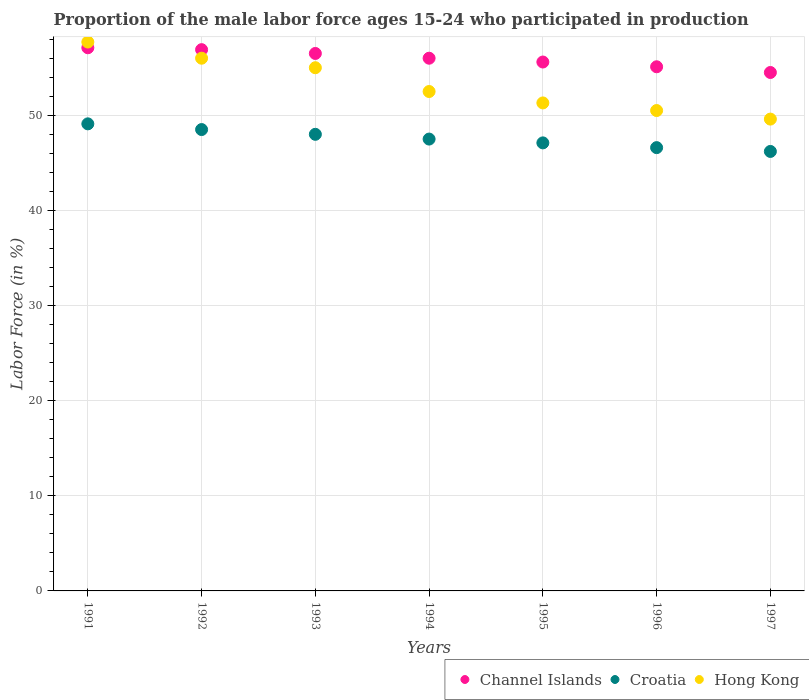Is the number of dotlines equal to the number of legend labels?
Make the answer very short. Yes. What is the proportion of the male labor force who participated in production in Hong Kong in 1997?
Offer a very short reply. 49.6. Across all years, what is the maximum proportion of the male labor force who participated in production in Croatia?
Give a very brief answer. 49.1. Across all years, what is the minimum proportion of the male labor force who participated in production in Channel Islands?
Ensure brevity in your answer.  54.5. In which year was the proportion of the male labor force who participated in production in Hong Kong maximum?
Offer a terse response. 1991. In which year was the proportion of the male labor force who participated in production in Hong Kong minimum?
Your response must be concise. 1997. What is the total proportion of the male labor force who participated in production in Channel Islands in the graph?
Give a very brief answer. 391.7. What is the difference between the proportion of the male labor force who participated in production in Hong Kong in 1991 and that in 1997?
Make the answer very short. 8.1. What is the difference between the proportion of the male labor force who participated in production in Hong Kong in 1991 and the proportion of the male labor force who participated in production in Channel Islands in 1992?
Your answer should be very brief. 0.8. What is the average proportion of the male labor force who participated in production in Channel Islands per year?
Your response must be concise. 55.96. What is the ratio of the proportion of the male labor force who participated in production in Channel Islands in 1995 to that in 1997?
Provide a short and direct response. 1.02. Is the difference between the proportion of the male labor force who participated in production in Channel Islands in 1991 and 1994 greater than the difference between the proportion of the male labor force who participated in production in Croatia in 1991 and 1994?
Your answer should be compact. No. What is the difference between the highest and the second highest proportion of the male labor force who participated in production in Channel Islands?
Provide a short and direct response. 0.2. What is the difference between the highest and the lowest proportion of the male labor force who participated in production in Channel Islands?
Your answer should be compact. 2.6. Is the sum of the proportion of the male labor force who participated in production in Croatia in 1991 and 1993 greater than the maximum proportion of the male labor force who participated in production in Channel Islands across all years?
Your response must be concise. Yes. Does the proportion of the male labor force who participated in production in Channel Islands monotonically increase over the years?
Your answer should be very brief. No. Is the proportion of the male labor force who participated in production in Channel Islands strictly greater than the proportion of the male labor force who participated in production in Croatia over the years?
Make the answer very short. Yes. Is the proportion of the male labor force who participated in production in Croatia strictly less than the proportion of the male labor force who participated in production in Channel Islands over the years?
Your answer should be compact. Yes. How many dotlines are there?
Provide a succinct answer. 3. Are the values on the major ticks of Y-axis written in scientific E-notation?
Your answer should be very brief. No. Does the graph contain grids?
Provide a short and direct response. Yes. Where does the legend appear in the graph?
Offer a terse response. Bottom right. What is the title of the graph?
Offer a terse response. Proportion of the male labor force ages 15-24 who participated in production. What is the label or title of the X-axis?
Make the answer very short. Years. What is the label or title of the Y-axis?
Offer a terse response. Labor Force (in %). What is the Labor Force (in %) in Channel Islands in 1991?
Offer a terse response. 57.1. What is the Labor Force (in %) in Croatia in 1991?
Offer a very short reply. 49.1. What is the Labor Force (in %) in Hong Kong in 1991?
Keep it short and to the point. 57.7. What is the Labor Force (in %) of Channel Islands in 1992?
Your response must be concise. 56.9. What is the Labor Force (in %) of Croatia in 1992?
Provide a succinct answer. 48.5. What is the Labor Force (in %) in Hong Kong in 1992?
Offer a terse response. 56. What is the Labor Force (in %) of Channel Islands in 1993?
Provide a succinct answer. 56.5. What is the Labor Force (in %) of Croatia in 1993?
Provide a succinct answer. 48. What is the Labor Force (in %) of Croatia in 1994?
Provide a short and direct response. 47.5. What is the Labor Force (in %) of Hong Kong in 1994?
Your answer should be compact. 52.5. What is the Labor Force (in %) of Channel Islands in 1995?
Provide a succinct answer. 55.6. What is the Labor Force (in %) of Croatia in 1995?
Make the answer very short. 47.1. What is the Labor Force (in %) of Hong Kong in 1995?
Your answer should be very brief. 51.3. What is the Labor Force (in %) in Channel Islands in 1996?
Keep it short and to the point. 55.1. What is the Labor Force (in %) of Croatia in 1996?
Ensure brevity in your answer.  46.6. What is the Labor Force (in %) in Hong Kong in 1996?
Your answer should be compact. 50.5. What is the Labor Force (in %) in Channel Islands in 1997?
Make the answer very short. 54.5. What is the Labor Force (in %) of Croatia in 1997?
Make the answer very short. 46.2. What is the Labor Force (in %) of Hong Kong in 1997?
Keep it short and to the point. 49.6. Across all years, what is the maximum Labor Force (in %) of Channel Islands?
Make the answer very short. 57.1. Across all years, what is the maximum Labor Force (in %) of Croatia?
Make the answer very short. 49.1. Across all years, what is the maximum Labor Force (in %) of Hong Kong?
Your answer should be compact. 57.7. Across all years, what is the minimum Labor Force (in %) of Channel Islands?
Your response must be concise. 54.5. Across all years, what is the minimum Labor Force (in %) of Croatia?
Your answer should be compact. 46.2. Across all years, what is the minimum Labor Force (in %) in Hong Kong?
Keep it short and to the point. 49.6. What is the total Labor Force (in %) of Channel Islands in the graph?
Ensure brevity in your answer.  391.7. What is the total Labor Force (in %) of Croatia in the graph?
Offer a terse response. 333. What is the total Labor Force (in %) of Hong Kong in the graph?
Offer a very short reply. 372.6. What is the difference between the Labor Force (in %) of Croatia in 1991 and that in 1993?
Provide a short and direct response. 1.1. What is the difference between the Labor Force (in %) of Croatia in 1991 and that in 1994?
Your response must be concise. 1.6. What is the difference between the Labor Force (in %) of Hong Kong in 1991 and that in 1994?
Make the answer very short. 5.2. What is the difference between the Labor Force (in %) of Channel Islands in 1991 and that in 1996?
Your answer should be compact. 2. What is the difference between the Labor Force (in %) of Croatia in 1991 and that in 1997?
Provide a succinct answer. 2.9. What is the difference between the Labor Force (in %) of Croatia in 1992 and that in 1993?
Your response must be concise. 0.5. What is the difference between the Labor Force (in %) in Hong Kong in 1992 and that in 1993?
Make the answer very short. 1. What is the difference between the Labor Force (in %) in Channel Islands in 1992 and that in 1994?
Make the answer very short. 0.9. What is the difference between the Labor Force (in %) in Channel Islands in 1992 and that in 1995?
Offer a terse response. 1.3. What is the difference between the Labor Force (in %) in Croatia in 1992 and that in 1996?
Make the answer very short. 1.9. What is the difference between the Labor Force (in %) in Hong Kong in 1992 and that in 1997?
Your answer should be very brief. 6.4. What is the difference between the Labor Force (in %) in Hong Kong in 1993 and that in 1994?
Provide a succinct answer. 2.5. What is the difference between the Labor Force (in %) in Channel Islands in 1993 and that in 1995?
Give a very brief answer. 0.9. What is the difference between the Labor Force (in %) of Croatia in 1993 and that in 1995?
Make the answer very short. 0.9. What is the difference between the Labor Force (in %) in Hong Kong in 1993 and that in 1995?
Ensure brevity in your answer.  3.7. What is the difference between the Labor Force (in %) of Channel Islands in 1993 and that in 1996?
Ensure brevity in your answer.  1.4. What is the difference between the Labor Force (in %) in Croatia in 1993 and that in 1996?
Your answer should be compact. 1.4. What is the difference between the Labor Force (in %) of Channel Islands in 1994 and that in 1995?
Keep it short and to the point. 0.4. What is the difference between the Labor Force (in %) of Croatia in 1994 and that in 1996?
Give a very brief answer. 0.9. What is the difference between the Labor Force (in %) in Hong Kong in 1994 and that in 1996?
Your answer should be very brief. 2. What is the difference between the Labor Force (in %) of Croatia in 1994 and that in 1997?
Provide a short and direct response. 1.3. What is the difference between the Labor Force (in %) of Hong Kong in 1994 and that in 1997?
Ensure brevity in your answer.  2.9. What is the difference between the Labor Force (in %) of Channel Islands in 1995 and that in 1997?
Your answer should be very brief. 1.1. What is the difference between the Labor Force (in %) of Channel Islands in 1996 and that in 1997?
Ensure brevity in your answer.  0.6. What is the difference between the Labor Force (in %) in Croatia in 1996 and that in 1997?
Ensure brevity in your answer.  0.4. What is the difference between the Labor Force (in %) in Hong Kong in 1996 and that in 1997?
Your answer should be compact. 0.9. What is the difference between the Labor Force (in %) of Channel Islands in 1991 and the Labor Force (in %) of Croatia in 1992?
Your answer should be compact. 8.6. What is the difference between the Labor Force (in %) in Channel Islands in 1991 and the Labor Force (in %) in Hong Kong in 1992?
Your response must be concise. 1.1. What is the difference between the Labor Force (in %) in Channel Islands in 1991 and the Labor Force (in %) in Croatia in 1993?
Provide a succinct answer. 9.1. What is the difference between the Labor Force (in %) of Channel Islands in 1991 and the Labor Force (in %) of Hong Kong in 1993?
Provide a short and direct response. 2.1. What is the difference between the Labor Force (in %) of Channel Islands in 1991 and the Labor Force (in %) of Hong Kong in 1994?
Provide a short and direct response. 4.6. What is the difference between the Labor Force (in %) of Croatia in 1991 and the Labor Force (in %) of Hong Kong in 1994?
Your response must be concise. -3.4. What is the difference between the Labor Force (in %) of Channel Islands in 1991 and the Labor Force (in %) of Hong Kong in 1995?
Your answer should be very brief. 5.8. What is the difference between the Labor Force (in %) of Croatia in 1991 and the Labor Force (in %) of Hong Kong in 1995?
Provide a succinct answer. -2.2. What is the difference between the Labor Force (in %) of Channel Islands in 1991 and the Labor Force (in %) of Hong Kong in 1996?
Your answer should be very brief. 6.6. What is the difference between the Labor Force (in %) in Croatia in 1991 and the Labor Force (in %) in Hong Kong in 1996?
Provide a short and direct response. -1.4. What is the difference between the Labor Force (in %) of Channel Islands in 1991 and the Labor Force (in %) of Hong Kong in 1997?
Your answer should be compact. 7.5. What is the difference between the Labor Force (in %) of Channel Islands in 1992 and the Labor Force (in %) of Hong Kong in 1993?
Your answer should be very brief. 1.9. What is the difference between the Labor Force (in %) of Channel Islands in 1992 and the Labor Force (in %) of Croatia in 1994?
Give a very brief answer. 9.4. What is the difference between the Labor Force (in %) in Channel Islands in 1992 and the Labor Force (in %) in Hong Kong in 1994?
Provide a succinct answer. 4.4. What is the difference between the Labor Force (in %) in Channel Islands in 1992 and the Labor Force (in %) in Croatia in 1995?
Your answer should be compact. 9.8. What is the difference between the Labor Force (in %) in Channel Islands in 1992 and the Labor Force (in %) in Hong Kong in 1995?
Your response must be concise. 5.6. What is the difference between the Labor Force (in %) in Croatia in 1992 and the Labor Force (in %) in Hong Kong in 1995?
Offer a very short reply. -2.8. What is the difference between the Labor Force (in %) in Channel Islands in 1992 and the Labor Force (in %) in Croatia in 1996?
Your answer should be very brief. 10.3. What is the difference between the Labor Force (in %) in Channel Islands in 1992 and the Labor Force (in %) in Hong Kong in 1996?
Provide a short and direct response. 6.4. What is the difference between the Labor Force (in %) in Croatia in 1992 and the Labor Force (in %) in Hong Kong in 1996?
Your answer should be very brief. -2. What is the difference between the Labor Force (in %) in Channel Islands in 1992 and the Labor Force (in %) in Croatia in 1997?
Offer a very short reply. 10.7. What is the difference between the Labor Force (in %) of Channel Islands in 1992 and the Labor Force (in %) of Hong Kong in 1997?
Offer a very short reply. 7.3. What is the difference between the Labor Force (in %) in Croatia in 1992 and the Labor Force (in %) in Hong Kong in 1997?
Offer a very short reply. -1.1. What is the difference between the Labor Force (in %) of Channel Islands in 1993 and the Labor Force (in %) of Croatia in 1994?
Provide a short and direct response. 9. What is the difference between the Labor Force (in %) of Channel Islands in 1993 and the Labor Force (in %) of Hong Kong in 1994?
Provide a short and direct response. 4. What is the difference between the Labor Force (in %) of Channel Islands in 1993 and the Labor Force (in %) of Hong Kong in 1995?
Offer a very short reply. 5.2. What is the difference between the Labor Force (in %) in Channel Islands in 1993 and the Labor Force (in %) in Croatia in 1996?
Provide a short and direct response. 9.9. What is the difference between the Labor Force (in %) in Channel Islands in 1993 and the Labor Force (in %) in Hong Kong in 1996?
Your answer should be very brief. 6. What is the difference between the Labor Force (in %) in Channel Islands in 1993 and the Labor Force (in %) in Croatia in 1997?
Your answer should be very brief. 10.3. What is the difference between the Labor Force (in %) in Channel Islands in 1993 and the Labor Force (in %) in Hong Kong in 1997?
Provide a succinct answer. 6.9. What is the difference between the Labor Force (in %) of Channel Islands in 1994 and the Labor Force (in %) of Hong Kong in 1995?
Keep it short and to the point. 4.7. What is the difference between the Labor Force (in %) in Croatia in 1994 and the Labor Force (in %) in Hong Kong in 1995?
Make the answer very short. -3.8. What is the difference between the Labor Force (in %) in Channel Islands in 1994 and the Labor Force (in %) in Croatia in 1996?
Provide a succinct answer. 9.4. What is the difference between the Labor Force (in %) in Channel Islands in 1994 and the Labor Force (in %) in Hong Kong in 1996?
Provide a succinct answer. 5.5. What is the difference between the Labor Force (in %) in Croatia in 1994 and the Labor Force (in %) in Hong Kong in 1996?
Your answer should be compact. -3. What is the difference between the Labor Force (in %) in Channel Islands in 1994 and the Labor Force (in %) in Croatia in 1997?
Offer a terse response. 9.8. What is the difference between the Labor Force (in %) of Channel Islands in 1994 and the Labor Force (in %) of Hong Kong in 1997?
Your answer should be very brief. 6.4. What is the difference between the Labor Force (in %) in Croatia in 1994 and the Labor Force (in %) in Hong Kong in 1997?
Make the answer very short. -2.1. What is the difference between the Labor Force (in %) in Channel Islands in 1995 and the Labor Force (in %) in Croatia in 1996?
Provide a short and direct response. 9. What is the difference between the Labor Force (in %) of Channel Islands in 1995 and the Labor Force (in %) of Hong Kong in 1996?
Give a very brief answer. 5.1. What is the difference between the Labor Force (in %) in Croatia in 1995 and the Labor Force (in %) in Hong Kong in 1996?
Give a very brief answer. -3.4. What is the difference between the Labor Force (in %) in Channel Islands in 1995 and the Labor Force (in %) in Croatia in 1997?
Your response must be concise. 9.4. What is the difference between the Labor Force (in %) of Channel Islands in 1995 and the Labor Force (in %) of Hong Kong in 1997?
Provide a succinct answer. 6. What is the difference between the Labor Force (in %) of Channel Islands in 1996 and the Labor Force (in %) of Croatia in 1997?
Your answer should be compact. 8.9. What is the difference between the Labor Force (in %) in Channel Islands in 1996 and the Labor Force (in %) in Hong Kong in 1997?
Ensure brevity in your answer.  5.5. What is the average Labor Force (in %) of Channel Islands per year?
Your answer should be compact. 55.96. What is the average Labor Force (in %) in Croatia per year?
Offer a very short reply. 47.57. What is the average Labor Force (in %) in Hong Kong per year?
Your answer should be compact. 53.23. In the year 1991, what is the difference between the Labor Force (in %) of Croatia and Labor Force (in %) of Hong Kong?
Give a very brief answer. -8.6. In the year 1992, what is the difference between the Labor Force (in %) of Channel Islands and Labor Force (in %) of Croatia?
Provide a succinct answer. 8.4. In the year 1993, what is the difference between the Labor Force (in %) of Channel Islands and Labor Force (in %) of Hong Kong?
Ensure brevity in your answer.  1.5. In the year 1993, what is the difference between the Labor Force (in %) in Croatia and Labor Force (in %) in Hong Kong?
Your response must be concise. -7. In the year 1994, what is the difference between the Labor Force (in %) in Channel Islands and Labor Force (in %) in Hong Kong?
Give a very brief answer. 3.5. In the year 1994, what is the difference between the Labor Force (in %) in Croatia and Labor Force (in %) in Hong Kong?
Give a very brief answer. -5. In the year 1995, what is the difference between the Labor Force (in %) in Croatia and Labor Force (in %) in Hong Kong?
Keep it short and to the point. -4.2. In the year 1996, what is the difference between the Labor Force (in %) in Croatia and Labor Force (in %) in Hong Kong?
Give a very brief answer. -3.9. In the year 1997, what is the difference between the Labor Force (in %) of Channel Islands and Labor Force (in %) of Hong Kong?
Your response must be concise. 4.9. What is the ratio of the Labor Force (in %) of Channel Islands in 1991 to that in 1992?
Give a very brief answer. 1. What is the ratio of the Labor Force (in %) of Croatia in 1991 to that in 1992?
Ensure brevity in your answer.  1.01. What is the ratio of the Labor Force (in %) of Hong Kong in 1991 to that in 1992?
Your response must be concise. 1.03. What is the ratio of the Labor Force (in %) in Channel Islands in 1991 to that in 1993?
Give a very brief answer. 1.01. What is the ratio of the Labor Force (in %) in Croatia in 1991 to that in 1993?
Provide a short and direct response. 1.02. What is the ratio of the Labor Force (in %) in Hong Kong in 1991 to that in 1993?
Your answer should be very brief. 1.05. What is the ratio of the Labor Force (in %) of Channel Islands in 1991 to that in 1994?
Your answer should be compact. 1.02. What is the ratio of the Labor Force (in %) in Croatia in 1991 to that in 1994?
Provide a succinct answer. 1.03. What is the ratio of the Labor Force (in %) of Hong Kong in 1991 to that in 1994?
Your answer should be very brief. 1.1. What is the ratio of the Labor Force (in %) in Channel Islands in 1991 to that in 1995?
Give a very brief answer. 1.03. What is the ratio of the Labor Force (in %) in Croatia in 1991 to that in 1995?
Ensure brevity in your answer.  1.04. What is the ratio of the Labor Force (in %) of Hong Kong in 1991 to that in 1995?
Provide a succinct answer. 1.12. What is the ratio of the Labor Force (in %) of Channel Islands in 1991 to that in 1996?
Provide a succinct answer. 1.04. What is the ratio of the Labor Force (in %) in Croatia in 1991 to that in 1996?
Ensure brevity in your answer.  1.05. What is the ratio of the Labor Force (in %) in Hong Kong in 1991 to that in 1996?
Your response must be concise. 1.14. What is the ratio of the Labor Force (in %) in Channel Islands in 1991 to that in 1997?
Your answer should be compact. 1.05. What is the ratio of the Labor Force (in %) in Croatia in 1991 to that in 1997?
Your answer should be compact. 1.06. What is the ratio of the Labor Force (in %) in Hong Kong in 1991 to that in 1997?
Give a very brief answer. 1.16. What is the ratio of the Labor Force (in %) in Channel Islands in 1992 to that in 1993?
Provide a short and direct response. 1.01. What is the ratio of the Labor Force (in %) of Croatia in 1992 to that in 1993?
Provide a short and direct response. 1.01. What is the ratio of the Labor Force (in %) of Hong Kong in 1992 to that in 1993?
Offer a very short reply. 1.02. What is the ratio of the Labor Force (in %) in Channel Islands in 1992 to that in 1994?
Give a very brief answer. 1.02. What is the ratio of the Labor Force (in %) in Croatia in 1992 to that in 1994?
Offer a terse response. 1.02. What is the ratio of the Labor Force (in %) of Hong Kong in 1992 to that in 1994?
Make the answer very short. 1.07. What is the ratio of the Labor Force (in %) of Channel Islands in 1992 to that in 1995?
Your answer should be compact. 1.02. What is the ratio of the Labor Force (in %) in Croatia in 1992 to that in 1995?
Your answer should be compact. 1.03. What is the ratio of the Labor Force (in %) in Hong Kong in 1992 to that in 1995?
Provide a succinct answer. 1.09. What is the ratio of the Labor Force (in %) in Channel Islands in 1992 to that in 1996?
Give a very brief answer. 1.03. What is the ratio of the Labor Force (in %) of Croatia in 1992 to that in 1996?
Your answer should be compact. 1.04. What is the ratio of the Labor Force (in %) of Hong Kong in 1992 to that in 1996?
Make the answer very short. 1.11. What is the ratio of the Labor Force (in %) of Channel Islands in 1992 to that in 1997?
Ensure brevity in your answer.  1.04. What is the ratio of the Labor Force (in %) in Croatia in 1992 to that in 1997?
Your response must be concise. 1.05. What is the ratio of the Labor Force (in %) in Hong Kong in 1992 to that in 1997?
Give a very brief answer. 1.13. What is the ratio of the Labor Force (in %) of Channel Islands in 1993 to that in 1994?
Give a very brief answer. 1.01. What is the ratio of the Labor Force (in %) of Croatia in 1993 to that in 1994?
Provide a short and direct response. 1.01. What is the ratio of the Labor Force (in %) of Hong Kong in 1993 to that in 1994?
Your answer should be very brief. 1.05. What is the ratio of the Labor Force (in %) of Channel Islands in 1993 to that in 1995?
Your answer should be very brief. 1.02. What is the ratio of the Labor Force (in %) in Croatia in 1993 to that in 1995?
Keep it short and to the point. 1.02. What is the ratio of the Labor Force (in %) of Hong Kong in 1993 to that in 1995?
Offer a terse response. 1.07. What is the ratio of the Labor Force (in %) in Channel Islands in 1993 to that in 1996?
Keep it short and to the point. 1.03. What is the ratio of the Labor Force (in %) of Hong Kong in 1993 to that in 1996?
Make the answer very short. 1.09. What is the ratio of the Labor Force (in %) of Channel Islands in 1993 to that in 1997?
Provide a succinct answer. 1.04. What is the ratio of the Labor Force (in %) of Croatia in 1993 to that in 1997?
Your response must be concise. 1.04. What is the ratio of the Labor Force (in %) in Hong Kong in 1993 to that in 1997?
Provide a succinct answer. 1.11. What is the ratio of the Labor Force (in %) of Croatia in 1994 to that in 1995?
Your answer should be very brief. 1.01. What is the ratio of the Labor Force (in %) in Hong Kong in 1994 to that in 1995?
Give a very brief answer. 1.02. What is the ratio of the Labor Force (in %) in Channel Islands in 1994 to that in 1996?
Keep it short and to the point. 1.02. What is the ratio of the Labor Force (in %) of Croatia in 1994 to that in 1996?
Your response must be concise. 1.02. What is the ratio of the Labor Force (in %) of Hong Kong in 1994 to that in 1996?
Offer a very short reply. 1.04. What is the ratio of the Labor Force (in %) of Channel Islands in 1994 to that in 1997?
Keep it short and to the point. 1.03. What is the ratio of the Labor Force (in %) in Croatia in 1994 to that in 1997?
Your response must be concise. 1.03. What is the ratio of the Labor Force (in %) in Hong Kong in 1994 to that in 1997?
Ensure brevity in your answer.  1.06. What is the ratio of the Labor Force (in %) of Channel Islands in 1995 to that in 1996?
Provide a short and direct response. 1.01. What is the ratio of the Labor Force (in %) in Croatia in 1995 to that in 1996?
Keep it short and to the point. 1.01. What is the ratio of the Labor Force (in %) of Hong Kong in 1995 to that in 1996?
Your answer should be very brief. 1.02. What is the ratio of the Labor Force (in %) of Channel Islands in 1995 to that in 1997?
Offer a terse response. 1.02. What is the ratio of the Labor Force (in %) in Croatia in 1995 to that in 1997?
Make the answer very short. 1.02. What is the ratio of the Labor Force (in %) in Hong Kong in 1995 to that in 1997?
Ensure brevity in your answer.  1.03. What is the ratio of the Labor Force (in %) in Channel Islands in 1996 to that in 1997?
Make the answer very short. 1.01. What is the ratio of the Labor Force (in %) in Croatia in 1996 to that in 1997?
Provide a short and direct response. 1.01. What is the ratio of the Labor Force (in %) of Hong Kong in 1996 to that in 1997?
Provide a succinct answer. 1.02. What is the difference between the highest and the lowest Labor Force (in %) of Croatia?
Give a very brief answer. 2.9. 